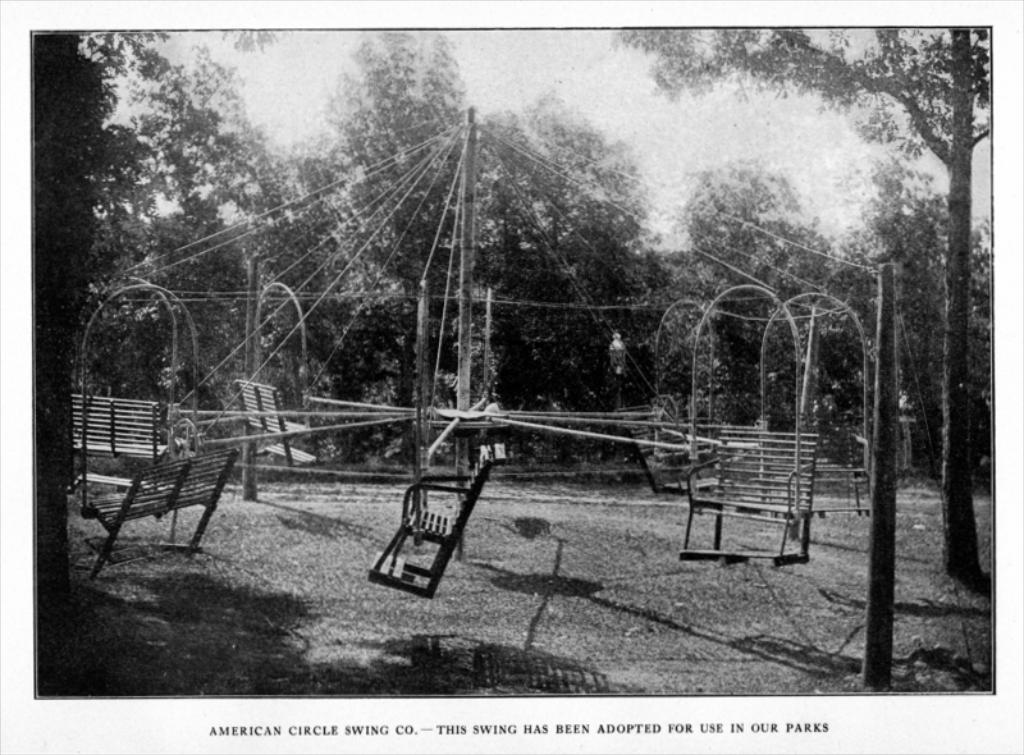What type of photograph is in the image? The image contains a black and white photograph. What is depicted in the photograph? The photograph depicts a metal frame swing. Where is the swing located? The swing is in a garden. What can be seen in the background of the photograph? There are trees visible in the background of the photograph. What type of crime is being committed in the image? There is no crime being committed in the image; it features a photograph of a metal frame swing in a garden. How many birds are sitting on the swing in the image? There are no birds present in the image. 